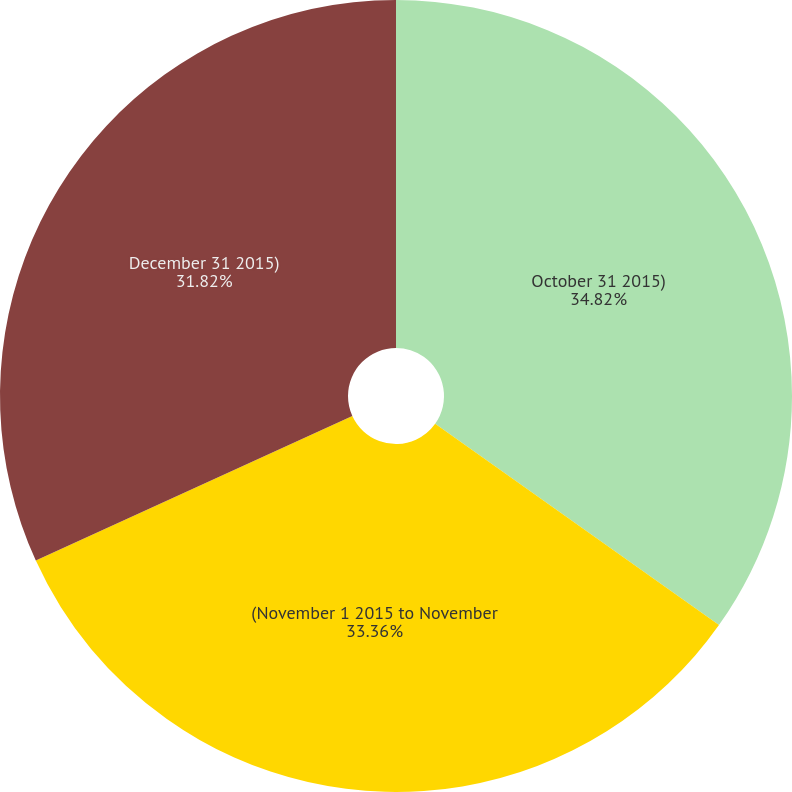<chart> <loc_0><loc_0><loc_500><loc_500><pie_chart><fcel>October 31 2015)<fcel>(November 1 2015 to November<fcel>December 31 2015)<nl><fcel>34.82%<fcel>33.36%<fcel>31.82%<nl></chart> 